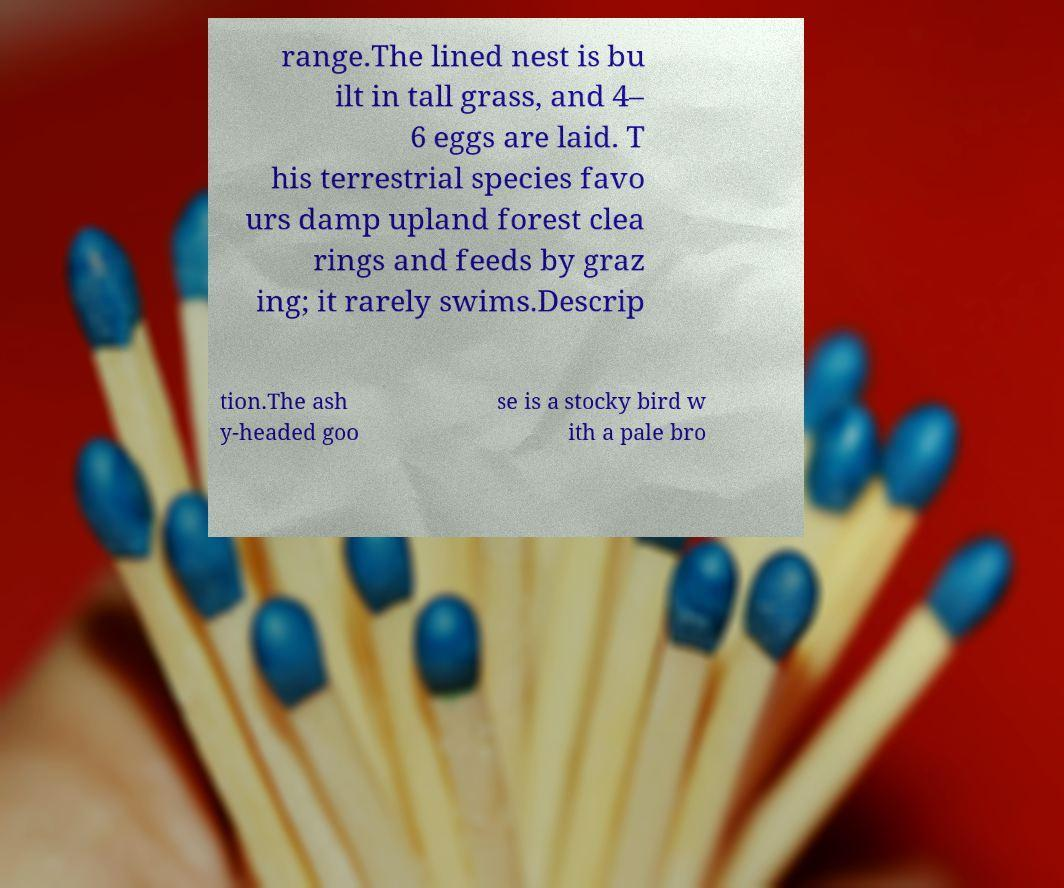Please read and relay the text visible in this image. What does it say? range.The lined nest is bu ilt in tall grass, and 4– 6 eggs are laid. T his terrestrial species favo urs damp upland forest clea rings and feeds by graz ing; it rarely swims.Descrip tion.The ash y-headed goo se is a stocky bird w ith a pale bro 